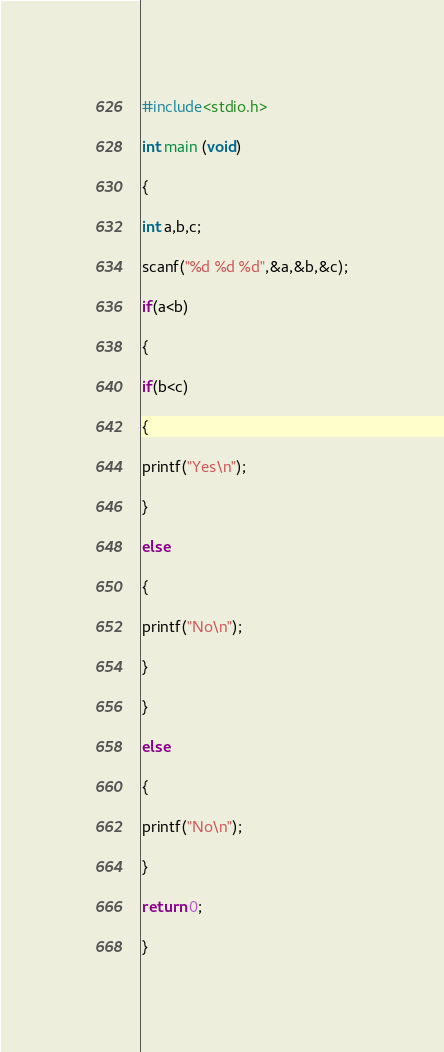Convert code to text. <code><loc_0><loc_0><loc_500><loc_500><_C_>#include<stdio.h>

int main (void)

{

int a,b,c;

scanf("%d %d %d",&a,&b,&c);

if(a<b)

{

if(b<c)

{

printf("Yes\n");

}

else

{

printf("No\n");

}

}

else

{

printf("No\n");

}

return 0;

}</code> 